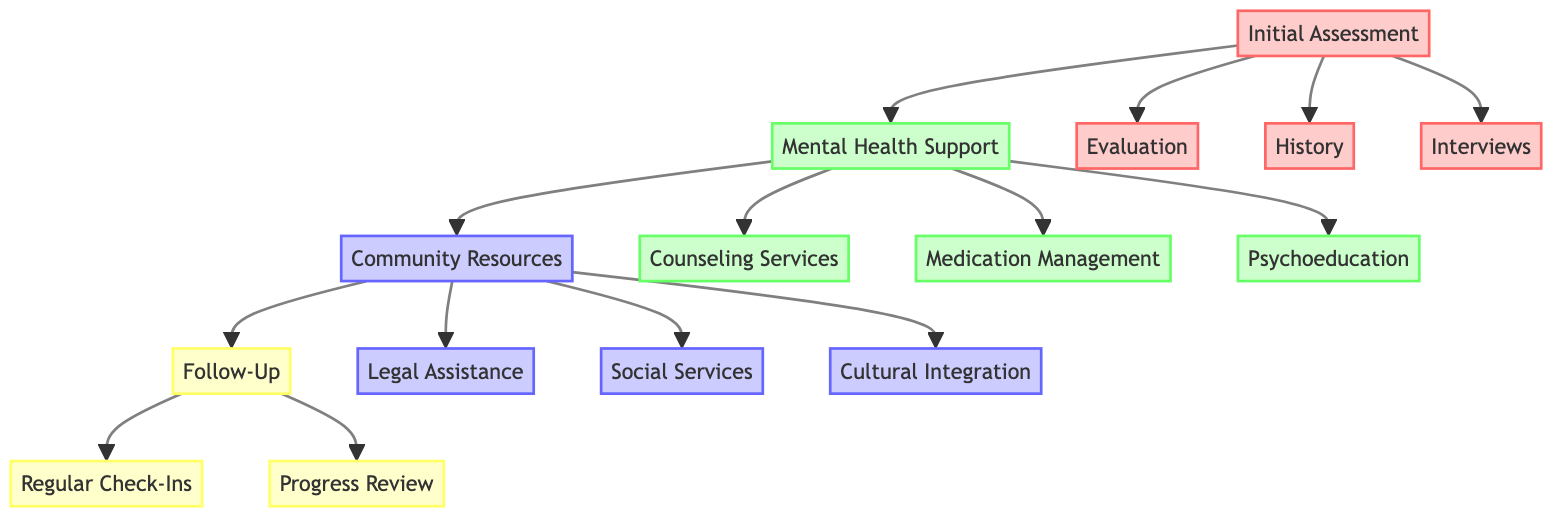What is the first step in the mental health support plan? The diagram indicates that the first step in the mental health support plan is "Initial Assessment." This is the starting point before moving on to further support measures.
Answer: Initial Assessment How many sections are there in the mental health support plan? By counting the main categories in the diagram, we find there are four sections: Initial Assessment, Mental Health Support, Community Resources, and Follow-Up.
Answer: Four What is included under Counseling Services? The diagram shows three specific services under Counseling Services: Individual Therapy, Group Therapy, and Family Therapy. These are essential parts of the mental health support.
Answer: Individual Therapy, Group Therapy, Family Therapy Which organization is listed for Psychoeducation on Coping Strategies? The diagram indicates that the organization for Psychoeducation concerning Coping Strategies is the National Alliance on Mental Illness. This is where individuals can receive support related to coping skills.
Answer: National Alliance on Mental Illness What follows after Community Resources in the pathway? The flow of the diagram shows that Follow-Up comes after Community Resources. This step is important for maintaining long-term support over time following initial assessments and resource connections.
Answer: Follow-Up What type of assistance is provided by the Immigrant Legal Resource Center? The diagram specifies that the Immigrant Legal Resource Center offers assistance with Asylum Applications, making it a crucial component of legal support in the community resources section.
Answer: Asylum Applications How often are Regular Check-Ins scheduled? According to the diagram, Regular Check-Ins are scheduled monthly, indicating a consistent follow-up approach to ensure support for asylum seekers is ongoing.
Answer: Monthly Which service falls under the Medication Management category? The diagram lists two components under Medication Management: Pharmacy and Prescriptions, both of which are essential for managing mental health through medication.
Answer: Pharmacy, Prescriptions What is the purpose of Family Interview in the Initial Assessment? The Family Interview's purpose is to collect interpersonal and background information that can influence the mental health assessment, vital for understanding the asylum seeker's situation.
Answer: Understanding background information What type of follow-up is conducted for Mental Health Progress? The diagram specifies that a Monthly Therapist Evaluation is conducted for assessing Mental Health Progress, highlighting a structured approach to monitoring mental health over time.
Answer: Monthly Therapist Evaluation 